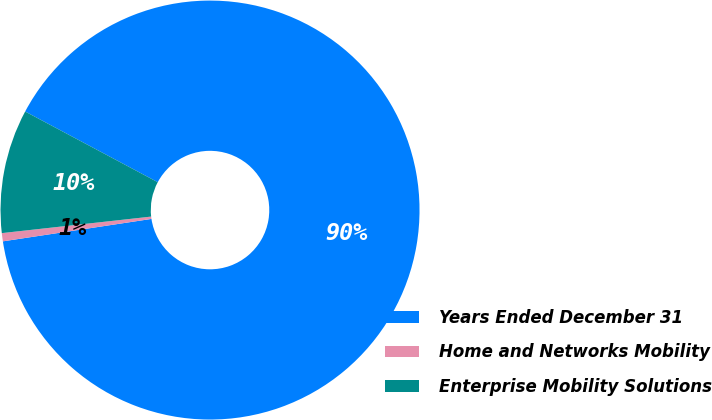<chart> <loc_0><loc_0><loc_500><loc_500><pie_chart><fcel>Years Ended December 31<fcel>Home and Networks Mobility<fcel>Enterprise Mobility Solutions<nl><fcel>89.83%<fcel>0.63%<fcel>9.55%<nl></chart> 